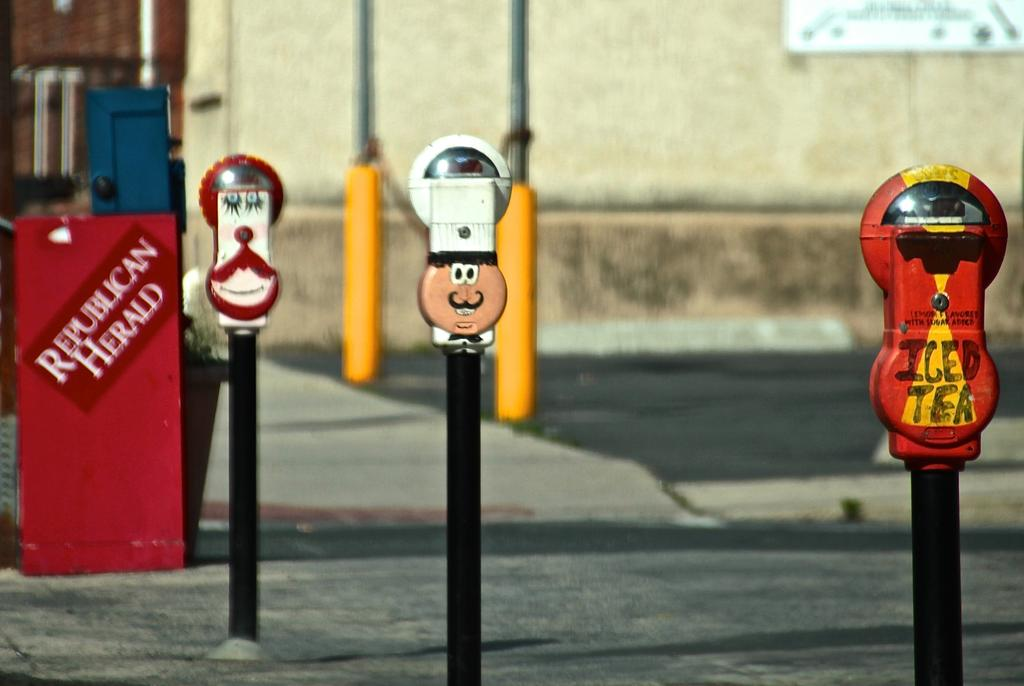<image>
Relay a brief, clear account of the picture shown. A red Republican Herald newspaper box behind some decorative parking meters. 